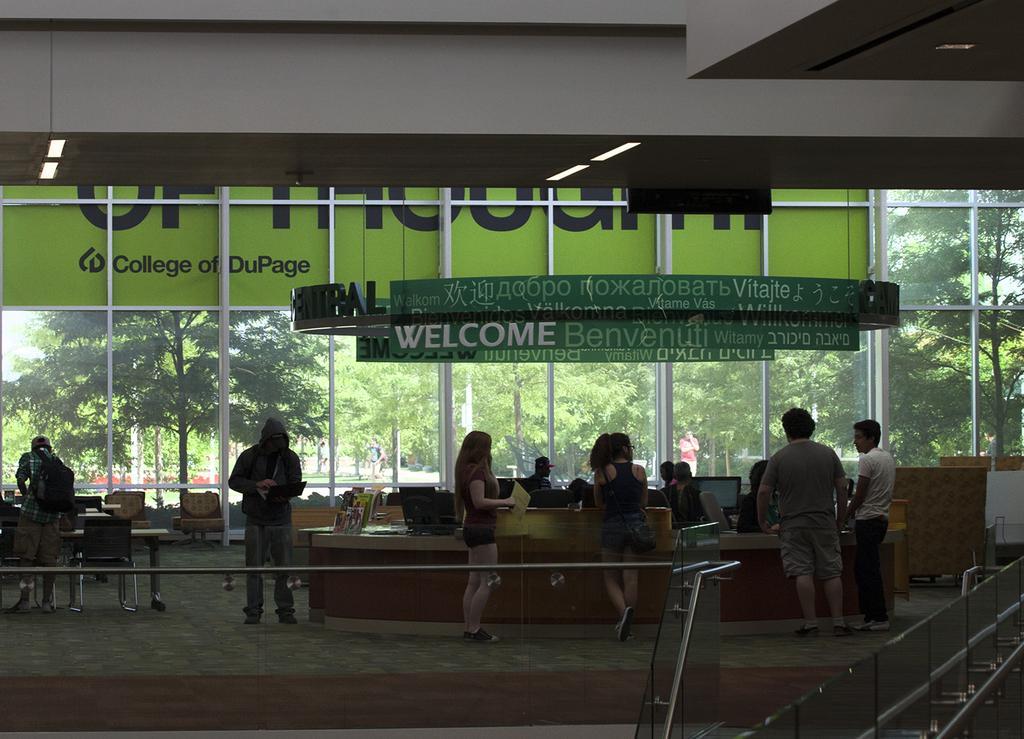Please provide a concise description of this image. As we can see in the picture that this is internal part of the building. Where many people are standing and working on the systems. There are chairs for people to sit on it. This is a floor and out side of the windows there are many trees and people are walking around. 